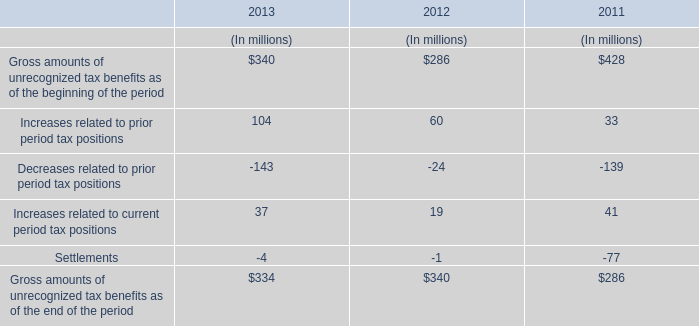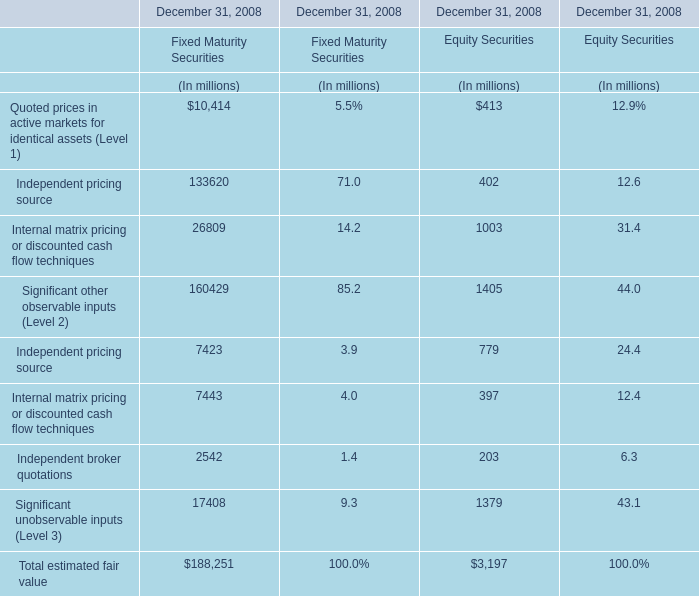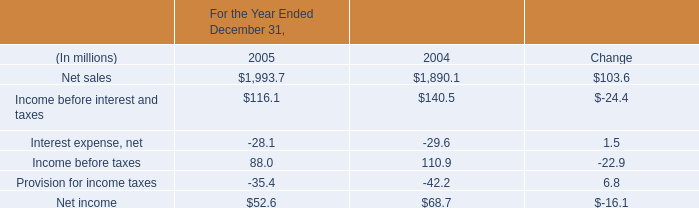Which Fixed Maturity Securities makes up more than 95% of the total in 2008? 
Answer: Internal matrix pricing or discounted cash flow techniques,Significant unobservable inputs (Level 3). 